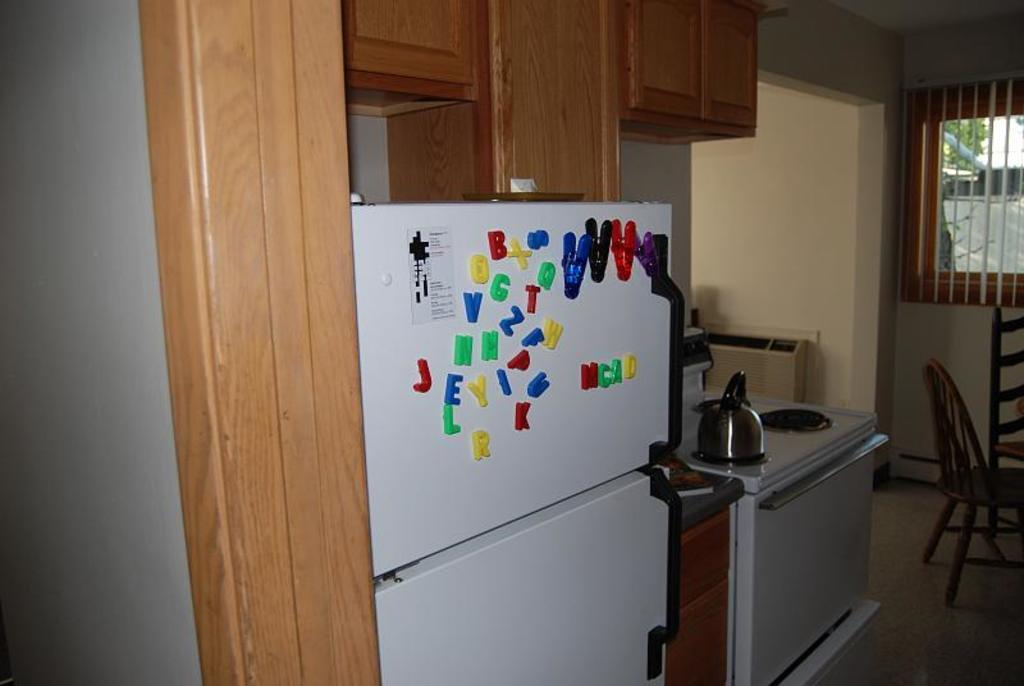<image>
Render a clear and concise summary of the photo. Magnetic letters on a refrigerator door. Four of them make up the word: MCAD 